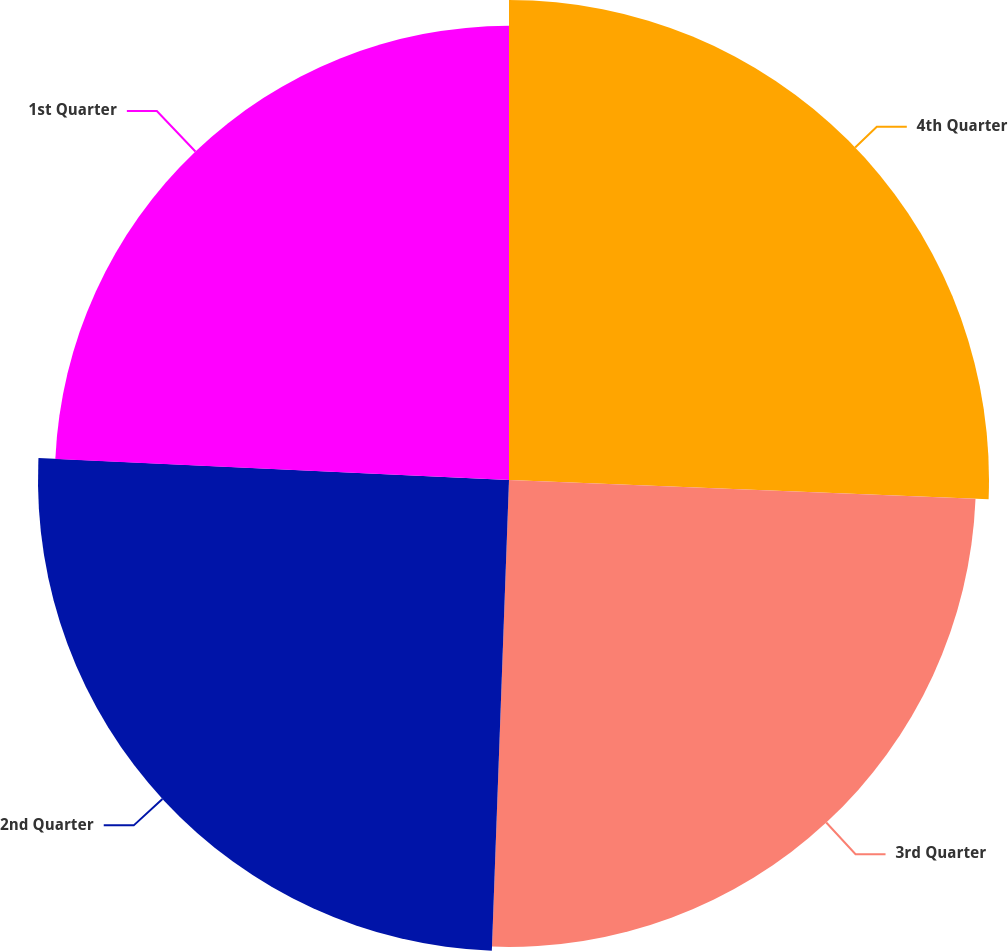<chart> <loc_0><loc_0><loc_500><loc_500><pie_chart><fcel>4th Quarter<fcel>3rd Quarter<fcel>2nd Quarter<fcel>1st Quarter<nl><fcel>25.64%<fcel>24.94%<fcel>25.16%<fcel>24.26%<nl></chart> 